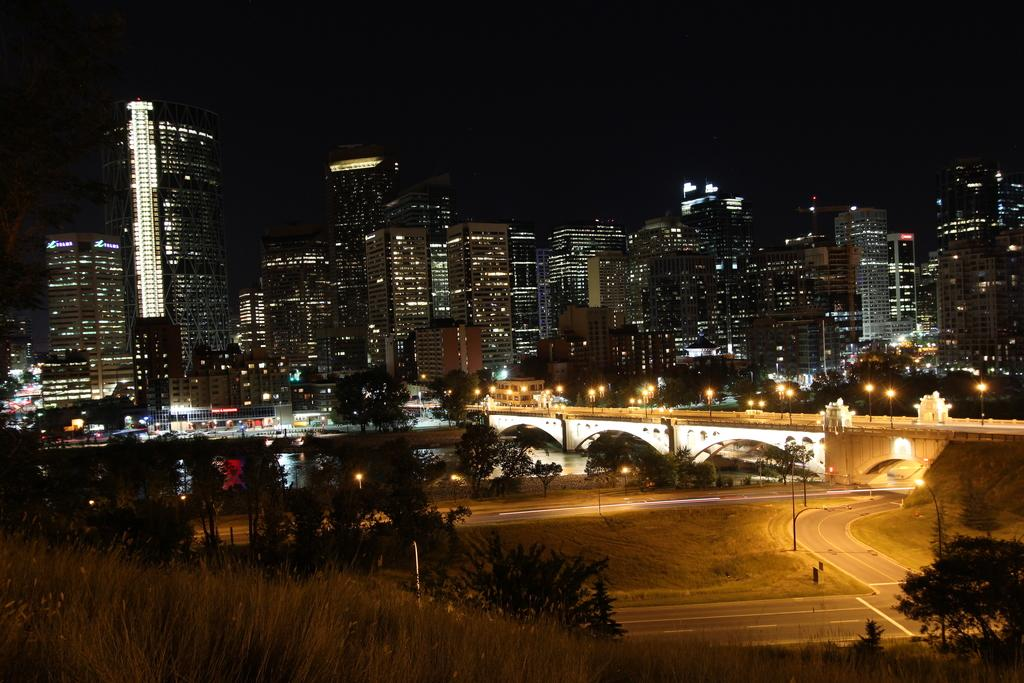What type of natural elements can be seen in the image? There are trees and water in the image. What man-made structure is present in the image? There is a bridge in the image. Are there any artificial light sources visible in the image? Yes, there are lights in the image. What type of human-made structures can be seen in the image? There are buildings in the image. How would you describe the overall lighting in the image? The image appears to be slightly dark. What type of feast is being prepared on the bridge in the image? There is no feast or any indication of food preparation in the image; it primarily features natural and man-made elements. Can you tell me how many boxes are visible on the bridge in the image? There are no boxes present on the bridge or anywhere else in the image. 